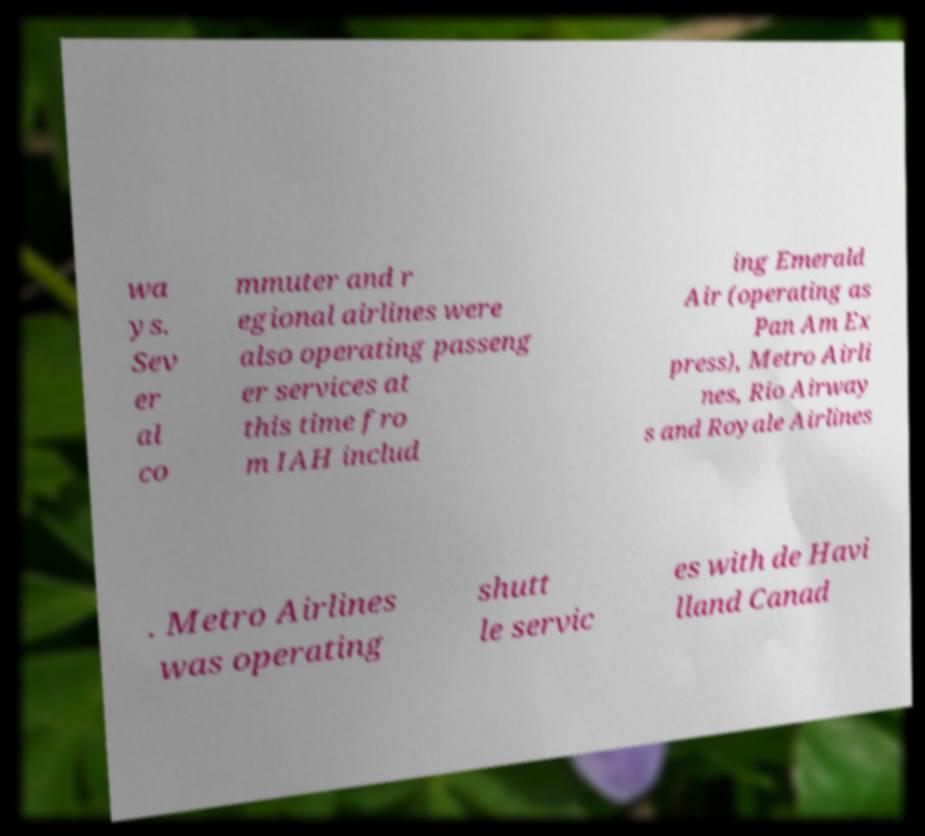Can you read and provide the text displayed in the image?This photo seems to have some interesting text. Can you extract and type it out for me? wa ys. Sev er al co mmuter and r egional airlines were also operating passeng er services at this time fro m IAH includ ing Emerald Air (operating as Pan Am Ex press), Metro Airli nes, Rio Airway s and Royale Airlines . Metro Airlines was operating shutt le servic es with de Havi lland Canad 